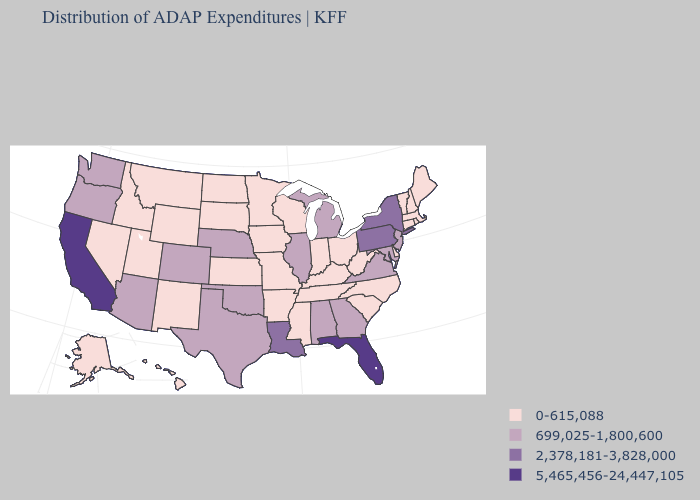Does Delaware have a lower value than Pennsylvania?
Answer briefly. Yes. What is the value of Hawaii?
Write a very short answer. 0-615,088. What is the value of Wisconsin?
Short answer required. 0-615,088. What is the value of Texas?
Give a very brief answer. 699,025-1,800,600. What is the value of Indiana?
Short answer required. 0-615,088. Which states have the lowest value in the USA?
Write a very short answer. Alaska, Arkansas, Connecticut, Delaware, Hawaii, Idaho, Indiana, Iowa, Kansas, Kentucky, Maine, Massachusetts, Minnesota, Mississippi, Missouri, Montana, Nevada, New Hampshire, New Mexico, North Carolina, North Dakota, Ohio, Rhode Island, South Carolina, South Dakota, Tennessee, Utah, Vermont, West Virginia, Wisconsin, Wyoming. Does Missouri have the lowest value in the USA?
Answer briefly. Yes. Is the legend a continuous bar?
Quick response, please. No. Does Illinois have the lowest value in the USA?
Quick response, please. No. Is the legend a continuous bar?
Short answer required. No. Does Pennsylvania have the lowest value in the Northeast?
Be succinct. No. Does New Jersey have the same value as Virginia?
Short answer required. Yes. What is the highest value in the South ?
Be succinct. 5,465,456-24,447,105. Does the map have missing data?
Keep it brief. No. 